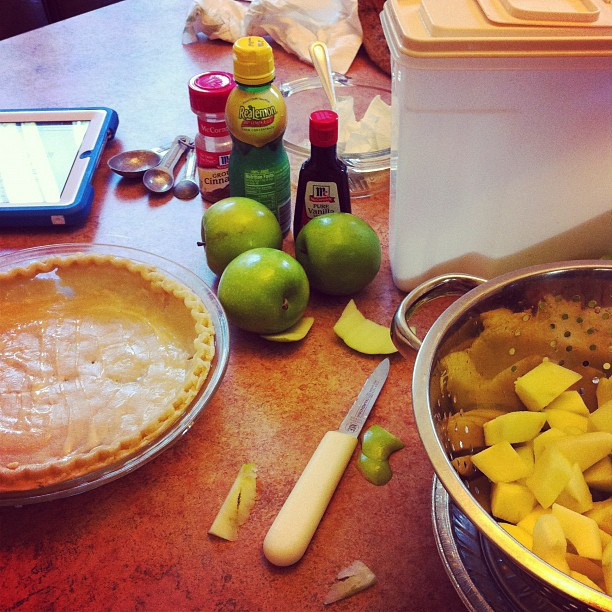<image>What color is the pans handle? I don't know what color the pan's handle is. It could be silver, black, or gray. What kind of nut is in the silver bowl? I don't know exactly what kind of nut is in the silver bowl. It could be pecans, cashew, brazil nut or almond, or there might be no nuts at all. What dairy products? It is ambiguous to identify the dairy products. What color is the pans handle? I don't know the color of the pan's handle. It can be silver, black, gray, or none. What dairy products? I don't know what dairy products are in the image. What kind of nut is in the silver bowl? I am not sure what kind of nut is in the silver bowl. There doesn't appear to be any nuts in the bowl in the image. 